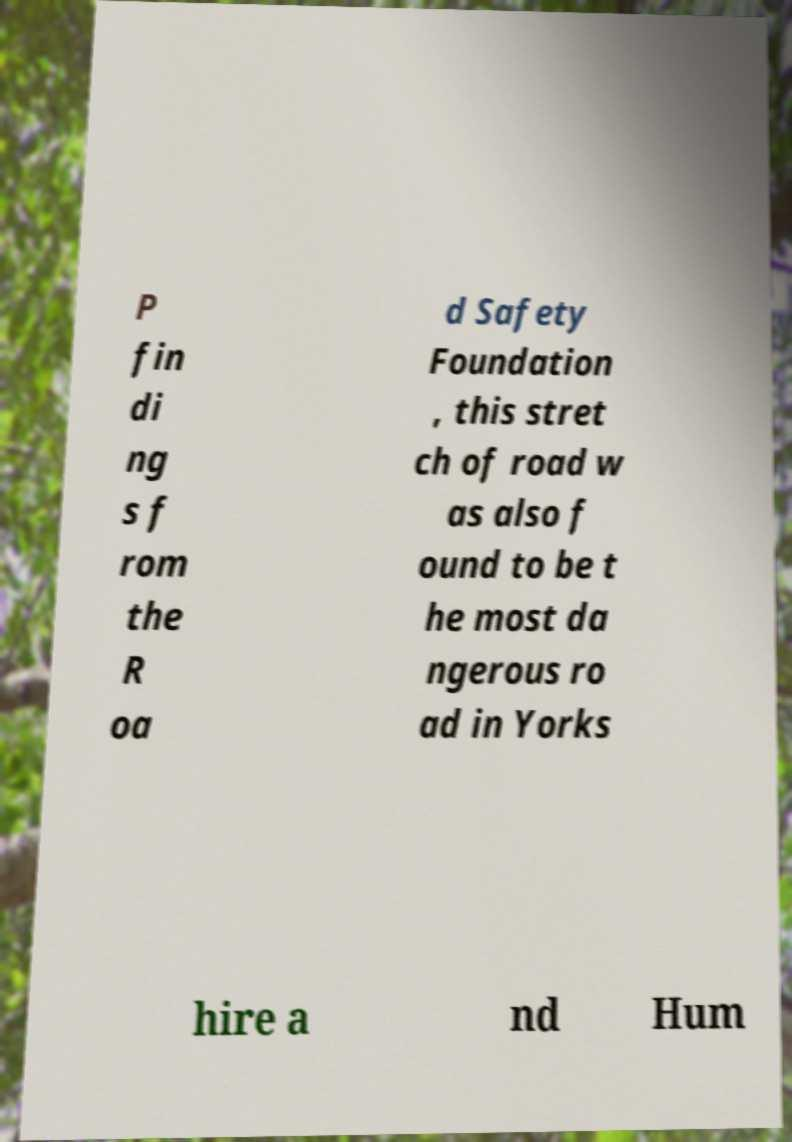Could you assist in decoding the text presented in this image and type it out clearly? P fin di ng s f rom the R oa d Safety Foundation , this stret ch of road w as also f ound to be t he most da ngerous ro ad in Yorks hire a nd Hum 